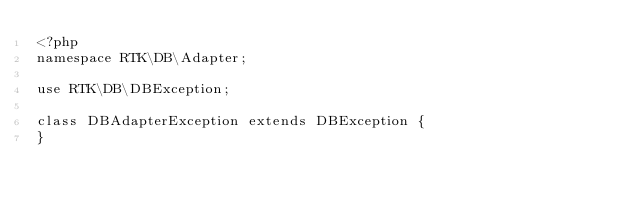<code> <loc_0><loc_0><loc_500><loc_500><_PHP_><?php
namespace RTK\DB\Adapter;

use RTK\DB\DBException;

class DBAdapterException extends DBException {
}
</code> 